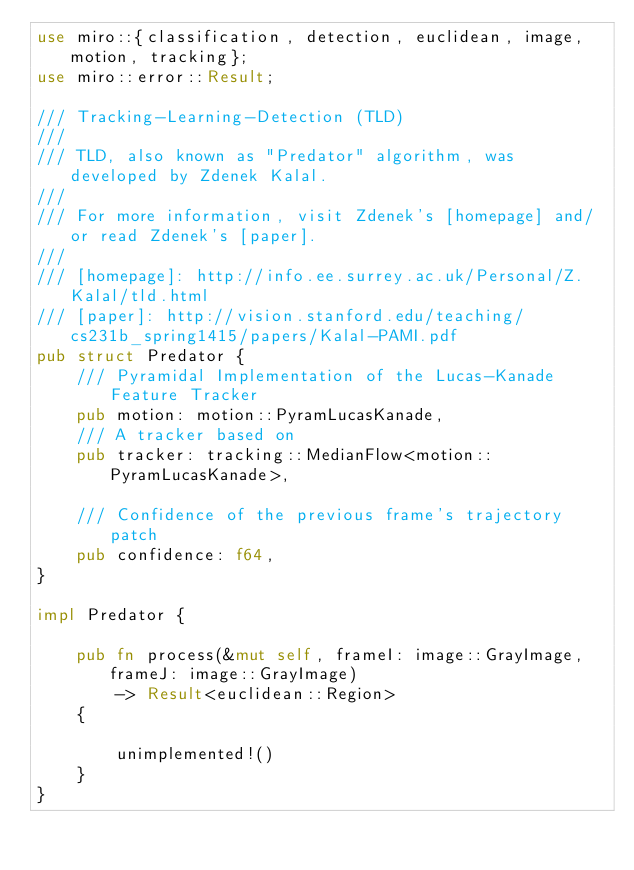<code> <loc_0><loc_0><loc_500><loc_500><_Rust_>use miro::{classification, detection, euclidean, image, motion, tracking};
use miro::error::Result;

/// Tracking-Learning-Detection (TLD)
///
/// TLD, also known as "Predator" algorithm, was developed by Zdenek Kalal.
///
/// For more information, visit Zdenek's [homepage] and/or read Zdenek's [paper].
///
/// [homepage]: http://info.ee.surrey.ac.uk/Personal/Z.Kalal/tld.html
/// [paper]: http://vision.stanford.edu/teaching/cs231b_spring1415/papers/Kalal-PAMI.pdf
pub struct Predator {
    /// Pyramidal Implementation of the Lucas-Kanade Feature Tracker
    pub motion: motion::PyramLucasKanade,
    /// A tracker based on
    pub tracker: tracking::MedianFlow<motion::PyramLucasKanade>,

    /// Confidence of the previous frame's trajectory patch
    pub confidence: f64,
}

impl Predator {

    pub fn process(&mut self, frameI: image::GrayImage, frameJ: image::GrayImage) 
        -> Result<euclidean::Region>
    {

        unimplemented!()
    }
}</code> 